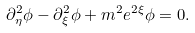<formula> <loc_0><loc_0><loc_500><loc_500>\partial ^ { 2 } _ { \eta } \phi - \partial ^ { 2 } _ { \xi } \phi + m ^ { 2 } e ^ { 2 \xi } \phi = 0 .</formula> 